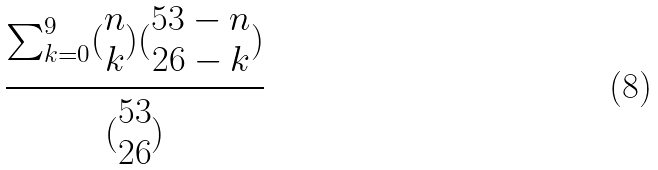Convert formula to latex. <formula><loc_0><loc_0><loc_500><loc_500>\frac { \sum _ { k = 0 } ^ { 9 } ( \begin{matrix} n \\ k \end{matrix} ) ( \begin{matrix} 5 3 - n \\ 2 6 - k \end{matrix} ) } { ( \begin{matrix} 5 3 \\ 2 6 \end{matrix} ) }</formula> 